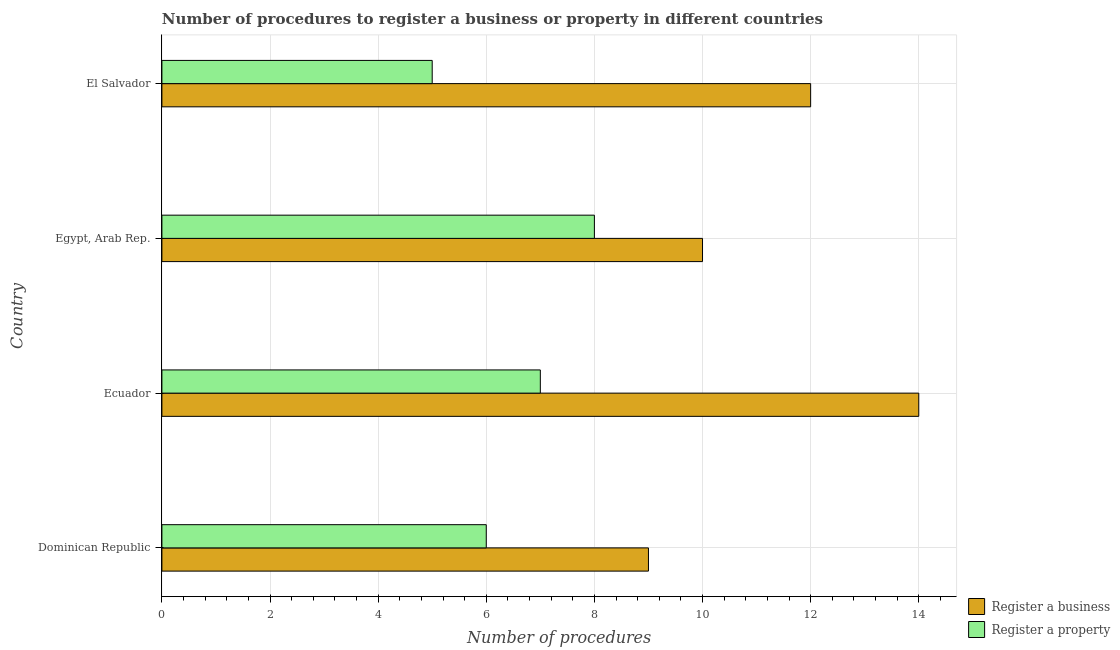How many different coloured bars are there?
Your answer should be very brief. 2. How many bars are there on the 2nd tick from the bottom?
Provide a succinct answer. 2. What is the label of the 2nd group of bars from the top?
Provide a short and direct response. Egypt, Arab Rep. In how many cases, is the number of bars for a given country not equal to the number of legend labels?
Provide a succinct answer. 0. What is the number of procedures to register a property in Egypt, Arab Rep.?
Your response must be concise. 8. Across all countries, what is the minimum number of procedures to register a business?
Offer a very short reply. 9. In which country was the number of procedures to register a property maximum?
Your answer should be very brief. Egypt, Arab Rep. In which country was the number of procedures to register a property minimum?
Your answer should be very brief. El Salvador. What is the total number of procedures to register a property in the graph?
Offer a very short reply. 26. What is the difference between the number of procedures to register a property in Ecuador and that in Egypt, Arab Rep.?
Make the answer very short. -1. What is the difference between the number of procedures to register a property in Dominican Republic and the number of procedures to register a business in Egypt, Arab Rep.?
Provide a short and direct response. -4. What is the difference between the number of procedures to register a property and number of procedures to register a business in Ecuador?
Your answer should be very brief. -7. What is the ratio of the number of procedures to register a property in Ecuador to that in Egypt, Arab Rep.?
Ensure brevity in your answer.  0.88. Is the difference between the number of procedures to register a business in Dominican Republic and El Salvador greater than the difference between the number of procedures to register a property in Dominican Republic and El Salvador?
Make the answer very short. No. What is the difference between the highest and the lowest number of procedures to register a property?
Your response must be concise. 3. What does the 1st bar from the top in El Salvador represents?
Give a very brief answer. Register a property. What does the 2nd bar from the bottom in El Salvador represents?
Provide a short and direct response. Register a property. How many bars are there?
Your response must be concise. 8. Are all the bars in the graph horizontal?
Offer a terse response. Yes. Does the graph contain any zero values?
Make the answer very short. No. Does the graph contain grids?
Ensure brevity in your answer.  Yes. What is the title of the graph?
Provide a succinct answer. Number of procedures to register a business or property in different countries. Does "Current US$" appear as one of the legend labels in the graph?
Give a very brief answer. No. What is the label or title of the X-axis?
Make the answer very short. Number of procedures. What is the label or title of the Y-axis?
Your answer should be compact. Country. What is the Number of procedures in Register a business in Dominican Republic?
Your answer should be compact. 9. What is the Number of procedures in Register a property in Dominican Republic?
Ensure brevity in your answer.  6. What is the Number of procedures of Register a property in El Salvador?
Your answer should be compact. 5. What is the total Number of procedures of Register a business in the graph?
Your answer should be compact. 45. What is the difference between the Number of procedures of Register a business in Dominican Republic and that in Egypt, Arab Rep.?
Your response must be concise. -1. What is the difference between the Number of procedures in Register a property in Dominican Republic and that in Egypt, Arab Rep.?
Offer a very short reply. -2. What is the difference between the Number of procedures in Register a business in Ecuador and that in Egypt, Arab Rep.?
Provide a short and direct response. 4. What is the difference between the Number of procedures in Register a property in Ecuador and that in Egypt, Arab Rep.?
Give a very brief answer. -1. What is the difference between the Number of procedures of Register a property in Egypt, Arab Rep. and that in El Salvador?
Your answer should be compact. 3. What is the difference between the Number of procedures of Register a business in Dominican Republic and the Number of procedures of Register a property in Ecuador?
Your answer should be compact. 2. What is the difference between the Number of procedures of Register a business in Dominican Republic and the Number of procedures of Register a property in El Salvador?
Ensure brevity in your answer.  4. What is the difference between the Number of procedures of Register a business in Ecuador and the Number of procedures of Register a property in El Salvador?
Your response must be concise. 9. What is the difference between the Number of procedures of Register a business in Egypt, Arab Rep. and the Number of procedures of Register a property in El Salvador?
Provide a short and direct response. 5. What is the average Number of procedures in Register a business per country?
Provide a succinct answer. 11.25. What is the average Number of procedures in Register a property per country?
Make the answer very short. 6.5. What is the difference between the Number of procedures in Register a business and Number of procedures in Register a property in Dominican Republic?
Provide a succinct answer. 3. What is the difference between the Number of procedures in Register a business and Number of procedures in Register a property in Ecuador?
Your response must be concise. 7. What is the difference between the Number of procedures in Register a business and Number of procedures in Register a property in El Salvador?
Your answer should be very brief. 7. What is the ratio of the Number of procedures of Register a business in Dominican Republic to that in Ecuador?
Your answer should be very brief. 0.64. What is the ratio of the Number of procedures in Register a property in Dominican Republic to that in Egypt, Arab Rep.?
Your response must be concise. 0.75. What is the ratio of the Number of procedures in Register a business in Dominican Republic to that in El Salvador?
Your response must be concise. 0.75. What is the ratio of the Number of procedures in Register a property in Dominican Republic to that in El Salvador?
Provide a succinct answer. 1.2. What is the ratio of the Number of procedures of Register a property in Ecuador to that in Egypt, Arab Rep.?
Your answer should be compact. 0.88. What is the ratio of the Number of procedures in Register a property in Ecuador to that in El Salvador?
Ensure brevity in your answer.  1.4. What is the difference between the highest and the second highest Number of procedures of Register a business?
Your response must be concise. 2. What is the difference between the highest and the second highest Number of procedures of Register a property?
Your answer should be very brief. 1. What is the difference between the highest and the lowest Number of procedures of Register a property?
Provide a short and direct response. 3. 